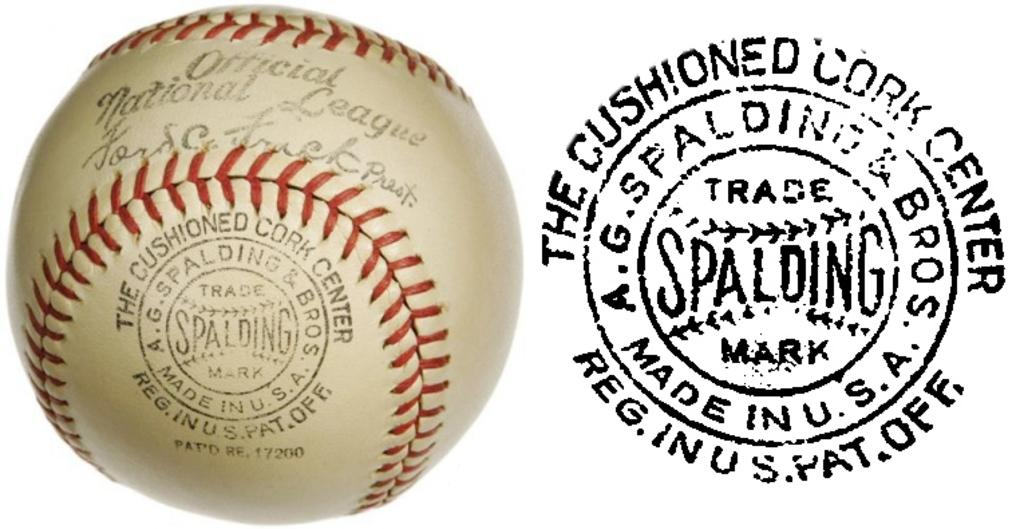<image>
Share a concise interpretation of the image provided. An Official National League baseball bearing the spalding logo next to the logo itself. 